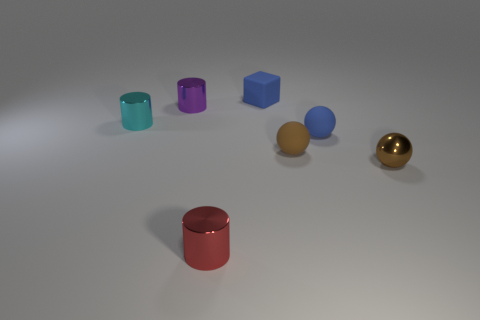Add 3 gray metal cubes. How many objects exist? 10 Subtract all balls. How many objects are left? 4 Add 4 rubber objects. How many rubber objects are left? 7 Add 4 blue cubes. How many blue cubes exist? 5 Subtract 0 green balls. How many objects are left? 7 Subtract all cyan things. Subtract all brown rubber spheres. How many objects are left? 5 